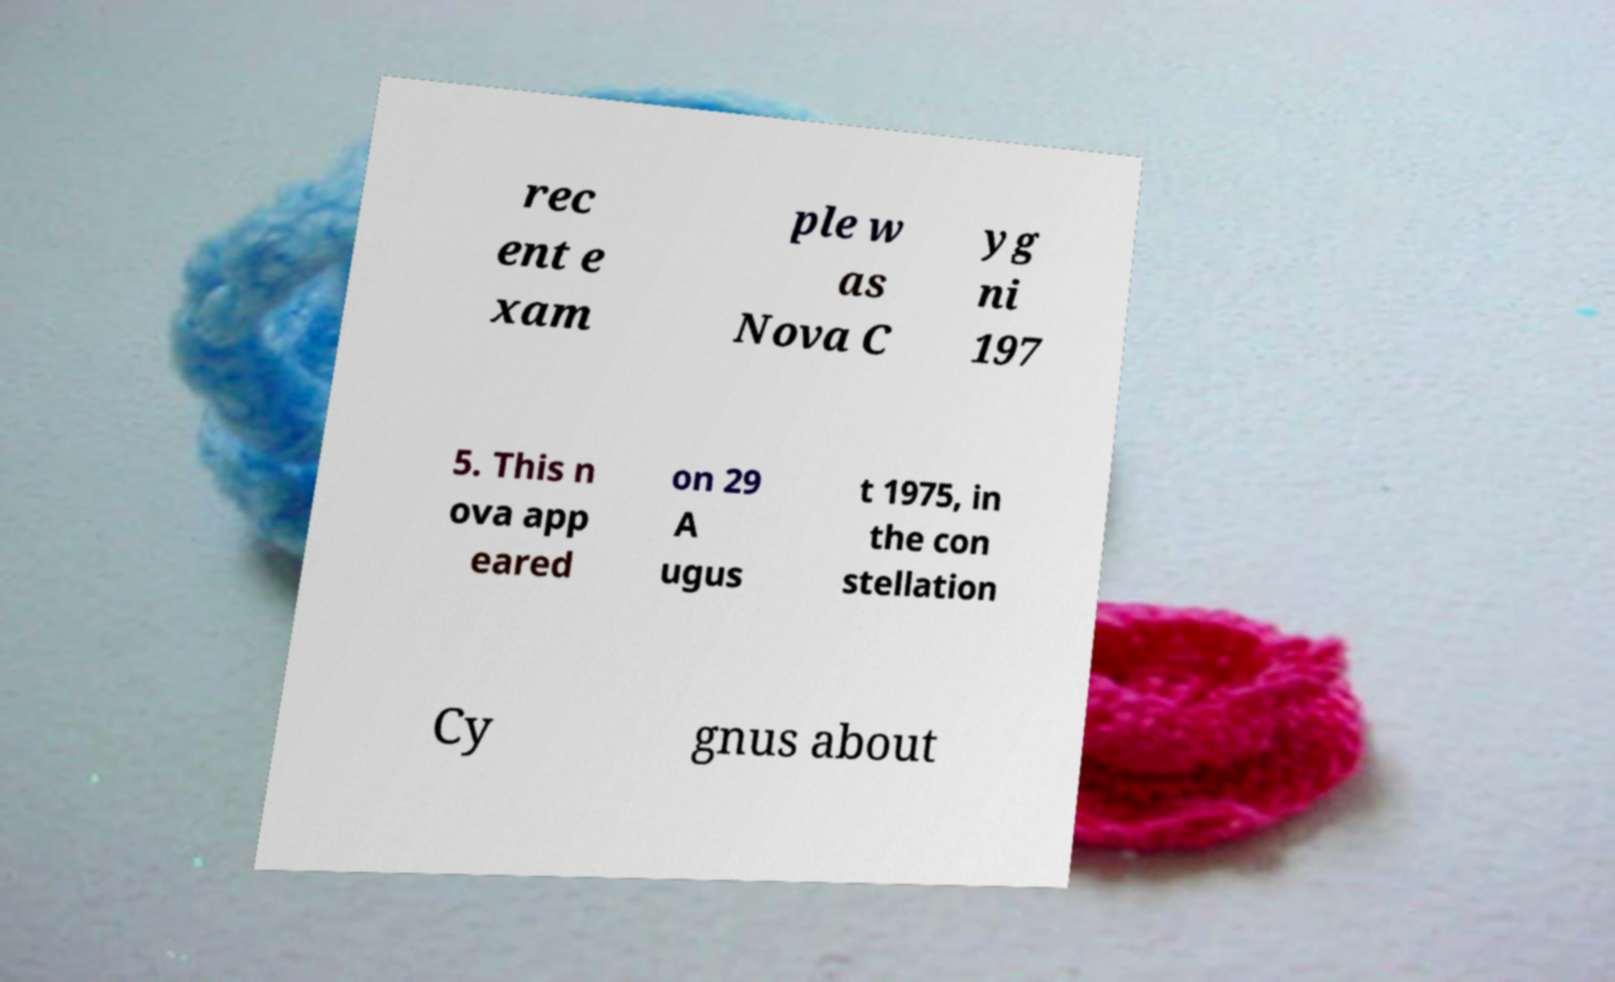Could you extract and type out the text from this image? rec ent e xam ple w as Nova C yg ni 197 5. This n ova app eared on 29 A ugus t 1975, in the con stellation Cy gnus about 